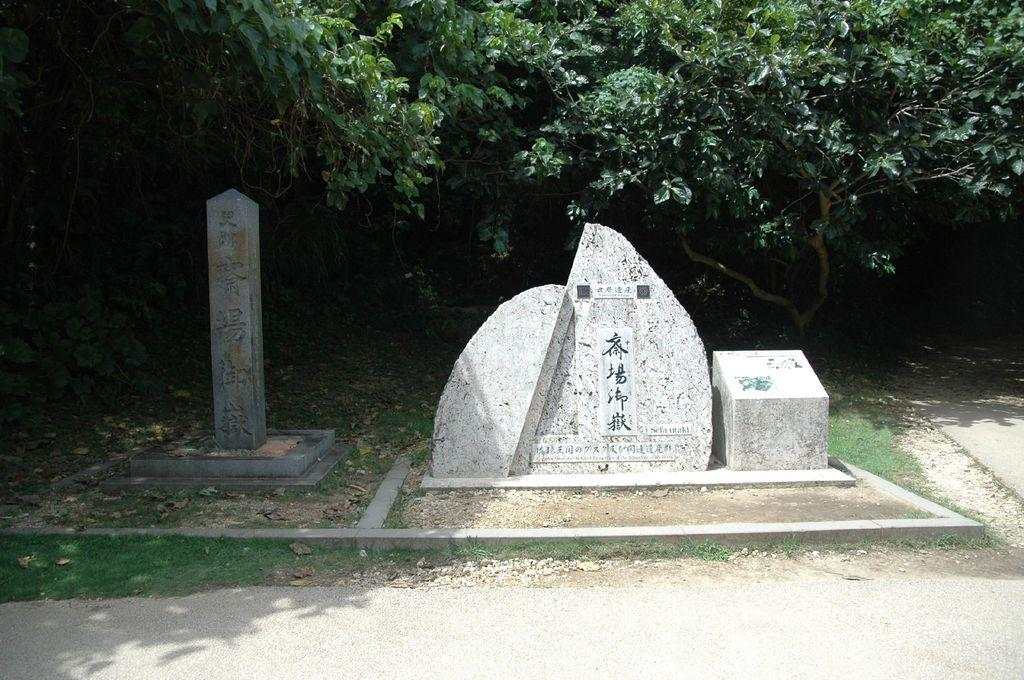What can be seen in the image related to burial or commemoration? There are two headstones in the image. What information is provided on the headstones? There is writing on the headstones. What can be seen in the background of the image? There are trees in the background of the image. What type of ant can be seen crawling in the alley in the image? There is no ant or alley present in the image; it features two headstones with writing and trees in the background. 